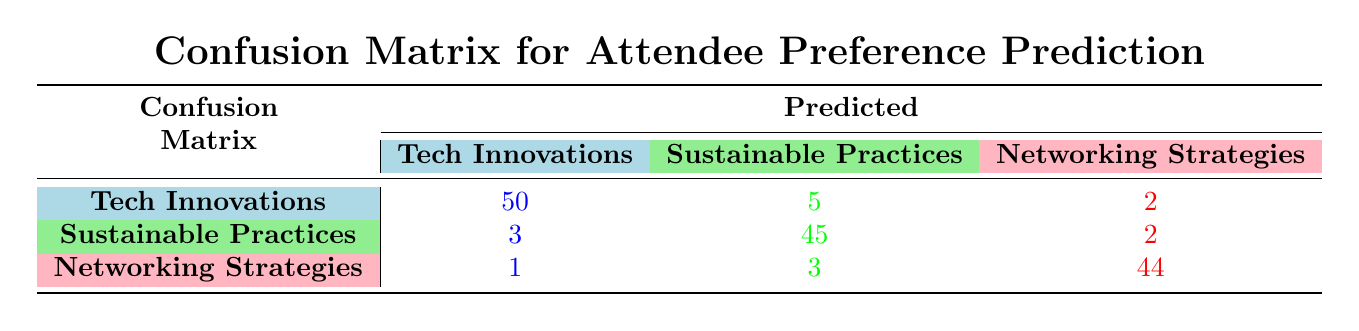What is the total number of attendees who preferred Tech Innovations? To find the total number of attendees for Tech Innovations, we look at the first row of the confusion matrix, which shows 50 attendees predicted as Tech Innovations correctly and also 5 incorrectly predicted as Sustainable Practices, plus 2 incorrectly predicted as Networking Strategies. So, the total is 50 + 5 + 2 = 57.
Answer: 57 What is the number of attendees who actually preferred Networking Strategies? Looking at the last row of the confusion matrix, we note that there are 1 correctly predicted as Tech Innovations, 3 as Sustainable Practices, and 44 as Networking Strategies. Therefore, to find the total number of attendees who preferred Networking Strategies, we sum these values: 1 + 3 + 44 = 48.
Answer: 48 How many attendees were predicted as preferring Sustainable Practices? From the second row, the values indicate that 3 are predicted as Tech Innovations, 45 as Sustainable Practices, and 2 as Networking Strategies. Thus, summing these values gives us 3 + 45 + 2 = 50 attendees predicted as preferring Sustainable Practices.
Answer: 50 Is it true that more attendees preferred Tech Innovations than Networking Strategies? Comparing the total counts, Tech Innovations received 57 attendees (50 + 5 + 2), while Networking Strategies received a total of 48 (1 + 3 + 44). Since 57 is greater than 48, it is true that more attendees preferred Tech Innovations.
Answer: True What percentage of attendees who preferred Sustainable Practices were predicted correctly? To find the percentage of correctly predicted attendees who preferred Sustainable Practices, we take the correct prediction count of 45 from the second row and divide it by the total count of actual preferences for Sustainable Practices (45 + 3 + 2 = 50). This gives us (45 / 50) * 100 = 90%.
Answer: 90% What is the total number of incorrect predictions made for Networking Strategies? To find the total incorrect predictions for Networking Strategies, we refer to the last row in the confusion matrix. The incorrect predictions for Networking Strategies are those predicted as Tech Innovations (1) and Sustainable Practices (3). Thus, the total number of incorrect predictions is 1 + 3 = 4.
Answer: 4 How many attendees were correctly predicted as preferring Tech Innovations? Referring to the first row's 'Tech Innovations' column, we see that the count is 50 attendees correctly predicted as preferring Tech Innovations.
Answer: 50 If the predictions were perfect, how many total attendees would be expected for Sustainable Practices? A perfect prediction means that all attendees who preferred Sustainable Practices would be predicted correctly. The actual count for attendees who preferred Sustainable Practices is given as 45 (correct predictions) + 3 (incorrectly predicted as Tech Innovations) + 2 (incorrectly predicted as Networking Strategies), which sums to 50. Hence, under perfect conditions, we would expect 50 attendees.
Answer: 50 What is the overall total number of attendees across all preferences? To find the overall total, we sum all values in the confusion matrix. For Tech Innovations: 50 + 5 + 2 = 57; for Sustainable Practices: 3 + 45 + 2 = 50; and for Networking Strategies: 1 + 3 + 44 = 48. Therefore, the overall total is 57 + 50 + 48 = 155.
Answer: 155 